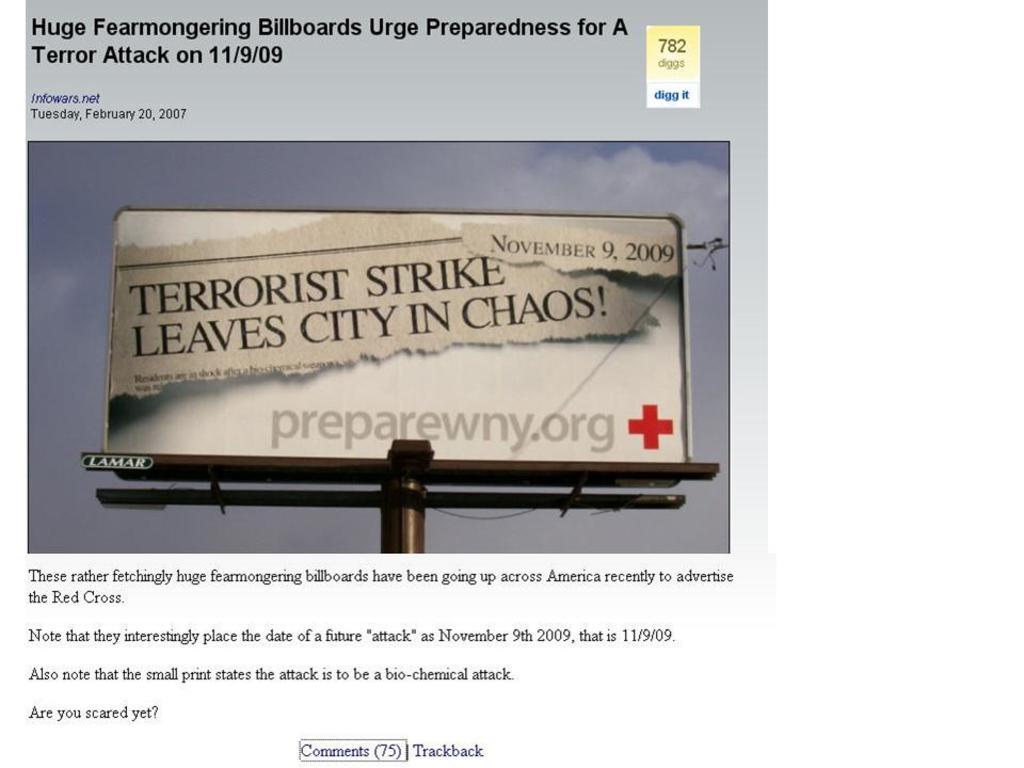When was the supposed terrorist attack to take place?
Make the answer very short. November 9, 2009. What is the url?
Your answer should be compact. Preparewny.org. 